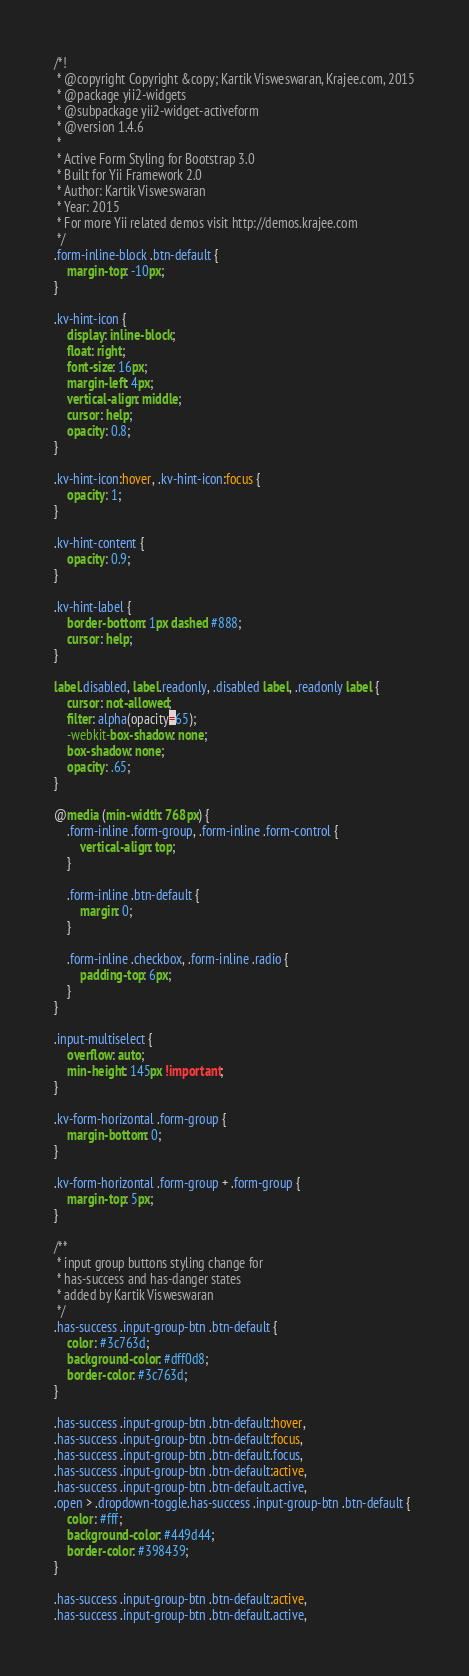Convert code to text. <code><loc_0><loc_0><loc_500><loc_500><_CSS_>/*!
 * @copyright Copyright &copy; Kartik Visweswaran, Krajee.com, 2015
 * @package yii2-widgets
 * @subpackage yii2-widget-activeform
 * @version 1.4.6
 *
 * Active Form Styling for Bootstrap 3.0
 * Built for Yii Framework 2.0
 * Author: Kartik Visweswaran
 * Year: 2015
 * For more Yii related demos visit http://demos.krajee.com
 */
.form-inline-block .btn-default {
    margin-top: -10px;
}

.kv-hint-icon {
    display: inline-block;
    float: right;
    font-size: 16px;
    margin-left: 4px;
    vertical-align: middle;
    cursor: help;
    opacity: 0.8;
}

.kv-hint-icon:hover, .kv-hint-icon:focus {
    opacity: 1;
}

.kv-hint-content {
    opacity: 0.9;
}

.kv-hint-label {
    border-bottom: 1px dashed #888;
    cursor: help;
}

label.disabled, label.readonly, .disabled label, .readonly label {
    cursor: not-allowed;
    filter: alpha(opacity=65);
    -webkit-box-shadow: none;
    box-shadow: none;
    opacity: .65;
}

@media (min-width: 768px) {
    .form-inline .form-group, .form-inline .form-control {
        vertical-align: top;
    }

    .form-inline .btn-default {
        margin: 0;
    }

    .form-inline .checkbox, .form-inline .radio {
        padding-top: 6px;
    }
}

.input-multiselect {
    overflow: auto;
    min-height: 145px !important;
}

.kv-form-horizontal .form-group {
    margin-bottom: 0;
}

.kv-form-horizontal .form-group + .form-group {
    margin-top: 5px;
}

/**
 * input group buttons styling change for 
 * has-success and has-danger states
 * added by Kartik Visweswaran
 */
.has-success .input-group-btn .btn-default {
    color: #3c763d;
    background-color: #dff0d8;
    border-color: #3c763d;
}

.has-success .input-group-btn .btn-default:hover,
.has-success .input-group-btn .btn-default:focus,
.has-success .input-group-btn .btn-default.focus,
.has-success .input-group-btn .btn-default:active,
.has-success .input-group-btn .btn-default.active,
.open > .dropdown-toggle.has-success .input-group-btn .btn-default {
    color: #fff;
    background-color: #449d44;
    border-color: #398439;
}

.has-success .input-group-btn .btn-default:active,
.has-success .input-group-btn .btn-default.active,</code> 